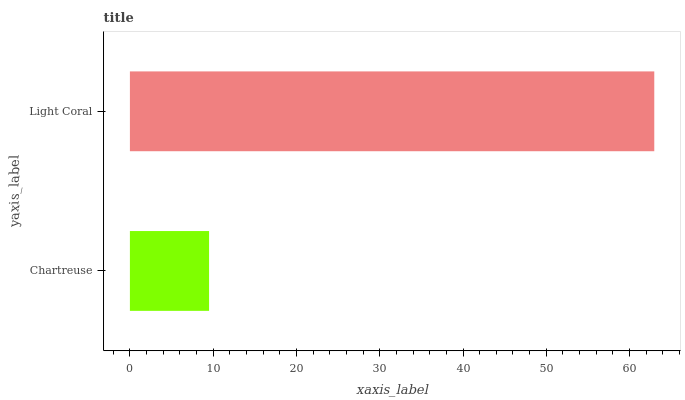Is Chartreuse the minimum?
Answer yes or no. Yes. Is Light Coral the maximum?
Answer yes or no. Yes. Is Light Coral the minimum?
Answer yes or no. No. Is Light Coral greater than Chartreuse?
Answer yes or no. Yes. Is Chartreuse less than Light Coral?
Answer yes or no. Yes. Is Chartreuse greater than Light Coral?
Answer yes or no. No. Is Light Coral less than Chartreuse?
Answer yes or no. No. Is Light Coral the high median?
Answer yes or no. Yes. Is Chartreuse the low median?
Answer yes or no. Yes. Is Chartreuse the high median?
Answer yes or no. No. Is Light Coral the low median?
Answer yes or no. No. 